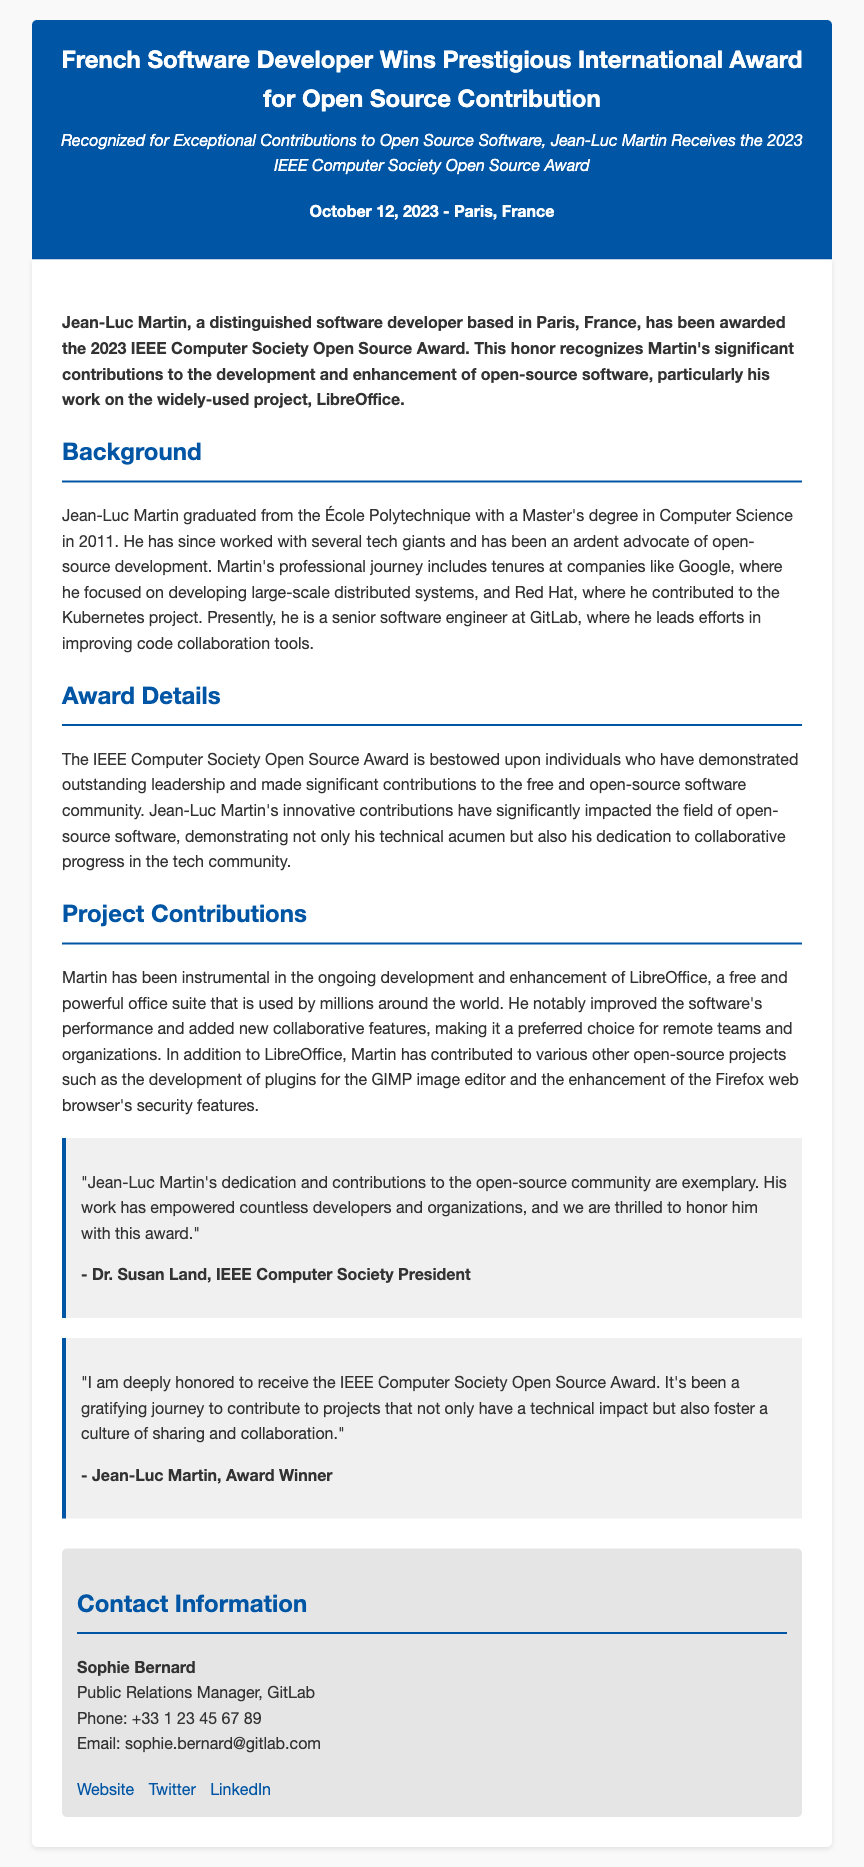What is the name of the award received? The award name is provided in the document under the section "Award Details."
Answer: 2023 IEEE Computer Society Open Source Award Who is the recipient of the award? The recipient's name is mentioned in the lead paragraph of the document.
Answer: Jean-Luc Martin When was the award announced? The date of the announcement is specified in the document's date-location section.
Answer: October 12, 2023 What project is Jean-Luc Martin primarily known for? The document highlights his significant work on LibreOffice under "Project Contributions."
Answer: LibreOffice What educational institution did Jean-Luc Martin graduate from? This information is in the "Background" section referring to his graduation.
Answer: École Polytechnique How many years has Jean-Luc Martin been working in the field as of 2023? The document states he graduated in 2011, so the calculation is 2023 - 2011.
Answer: 12 years What did Dr. Susan Land say about Jean-Luc Martin’s contributions? The quote from the document praises his dedication and contributions.
Answer: Exemplary Where does Jean-Luc Martin currently work? The document states his current job in the "Background" section.
Answer: GitLab What are the contact details of the Public Relations Manager? The document contains contact info for the PR manager in the contact info section.
Answer: Sophie Bernard, +33 1 23 45 67 89, sophie.bernard@gitlab.com 